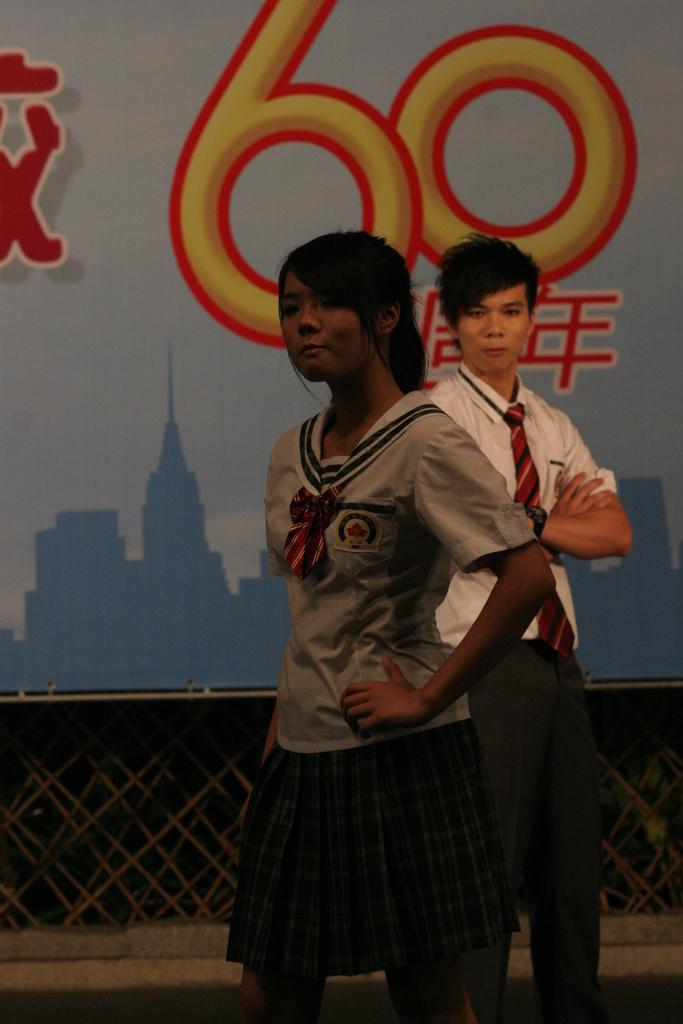How many people are present in the image? There are two people in the image, a woman and a man. What are the people in the image doing? The facts provided do not specify what the people are doing, but they are both standing. What can be seen in the background of the image? There is a wall with something written on it in the background of the image. What type of tree can be seen in the image? There is no tree present in the image. What flavor of eggnog is the man holding in the image? There is no eggnog present in the image. 